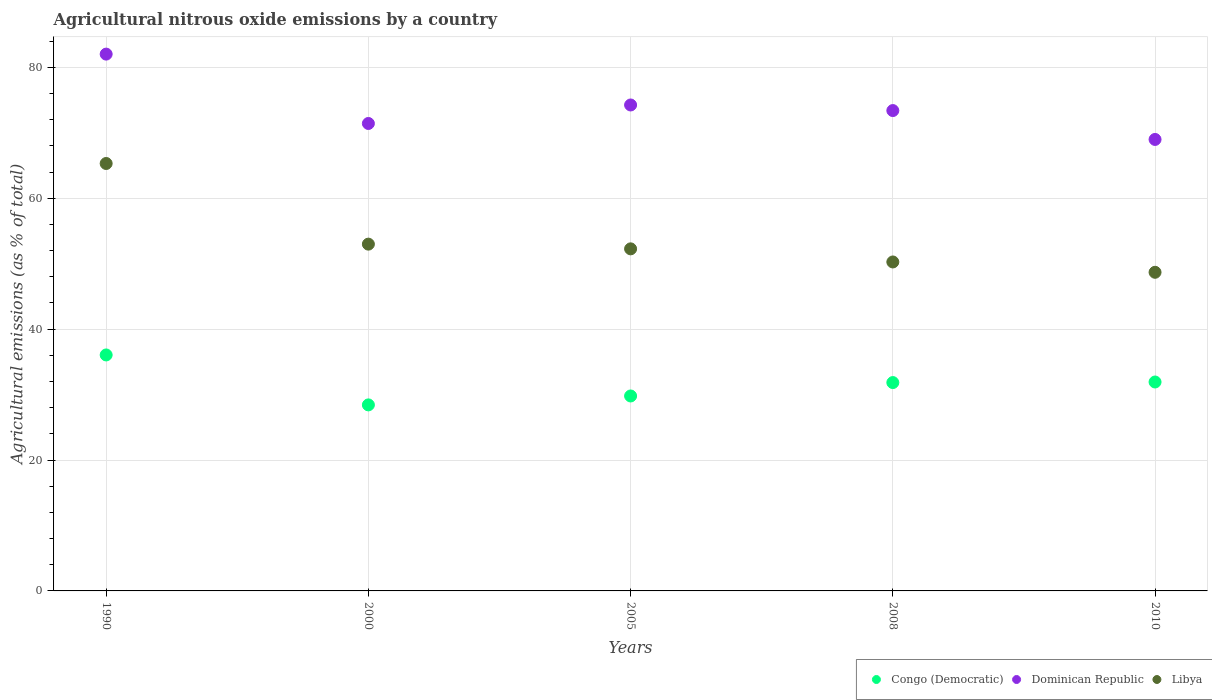What is the amount of agricultural nitrous oxide emitted in Libya in 2008?
Provide a short and direct response. 50.27. Across all years, what is the maximum amount of agricultural nitrous oxide emitted in Dominican Republic?
Offer a terse response. 82.03. Across all years, what is the minimum amount of agricultural nitrous oxide emitted in Congo (Democratic)?
Your answer should be compact. 28.43. In which year was the amount of agricultural nitrous oxide emitted in Congo (Democratic) minimum?
Ensure brevity in your answer.  2000. What is the total amount of agricultural nitrous oxide emitted in Libya in the graph?
Offer a terse response. 269.53. What is the difference between the amount of agricultural nitrous oxide emitted in Libya in 2000 and that in 2005?
Provide a short and direct response. 0.72. What is the difference between the amount of agricultural nitrous oxide emitted in Libya in 2000 and the amount of agricultural nitrous oxide emitted in Congo (Democratic) in 2008?
Offer a terse response. 21.15. What is the average amount of agricultural nitrous oxide emitted in Congo (Democratic) per year?
Your response must be concise. 31.61. In the year 2008, what is the difference between the amount of agricultural nitrous oxide emitted in Libya and amount of agricultural nitrous oxide emitted in Congo (Democratic)?
Give a very brief answer. 18.43. In how many years, is the amount of agricultural nitrous oxide emitted in Congo (Democratic) greater than 36 %?
Make the answer very short. 1. What is the ratio of the amount of agricultural nitrous oxide emitted in Libya in 2000 to that in 2010?
Offer a terse response. 1.09. Is the amount of agricultural nitrous oxide emitted in Dominican Republic in 1990 less than that in 2005?
Offer a very short reply. No. What is the difference between the highest and the second highest amount of agricultural nitrous oxide emitted in Libya?
Provide a succinct answer. 12.32. What is the difference between the highest and the lowest amount of agricultural nitrous oxide emitted in Libya?
Your answer should be very brief. 16.62. In how many years, is the amount of agricultural nitrous oxide emitted in Libya greater than the average amount of agricultural nitrous oxide emitted in Libya taken over all years?
Your answer should be very brief. 1. Does the amount of agricultural nitrous oxide emitted in Libya monotonically increase over the years?
Your answer should be very brief. No. Is the amount of agricultural nitrous oxide emitted in Congo (Democratic) strictly greater than the amount of agricultural nitrous oxide emitted in Dominican Republic over the years?
Ensure brevity in your answer.  No. Is the amount of agricultural nitrous oxide emitted in Congo (Democratic) strictly less than the amount of agricultural nitrous oxide emitted in Libya over the years?
Your answer should be very brief. Yes. Are the values on the major ticks of Y-axis written in scientific E-notation?
Ensure brevity in your answer.  No. Does the graph contain any zero values?
Your answer should be compact. No. Where does the legend appear in the graph?
Your response must be concise. Bottom right. How are the legend labels stacked?
Your answer should be compact. Horizontal. What is the title of the graph?
Keep it short and to the point. Agricultural nitrous oxide emissions by a country. What is the label or title of the Y-axis?
Make the answer very short. Agricultural emissions (as % of total). What is the Agricultural emissions (as % of total) in Congo (Democratic) in 1990?
Your answer should be compact. 36.06. What is the Agricultural emissions (as % of total) in Dominican Republic in 1990?
Make the answer very short. 82.03. What is the Agricultural emissions (as % of total) of Libya in 1990?
Your answer should be very brief. 65.31. What is the Agricultural emissions (as % of total) in Congo (Democratic) in 2000?
Provide a succinct answer. 28.43. What is the Agricultural emissions (as % of total) in Dominican Republic in 2000?
Provide a succinct answer. 71.43. What is the Agricultural emissions (as % of total) in Libya in 2000?
Offer a very short reply. 52.99. What is the Agricultural emissions (as % of total) of Congo (Democratic) in 2005?
Your answer should be very brief. 29.79. What is the Agricultural emissions (as % of total) in Dominican Republic in 2005?
Provide a succinct answer. 74.25. What is the Agricultural emissions (as % of total) in Libya in 2005?
Your answer should be compact. 52.27. What is the Agricultural emissions (as % of total) in Congo (Democratic) in 2008?
Your answer should be compact. 31.84. What is the Agricultural emissions (as % of total) of Dominican Republic in 2008?
Provide a short and direct response. 73.4. What is the Agricultural emissions (as % of total) in Libya in 2008?
Your answer should be compact. 50.27. What is the Agricultural emissions (as % of total) in Congo (Democratic) in 2010?
Offer a terse response. 31.92. What is the Agricultural emissions (as % of total) of Dominican Republic in 2010?
Offer a very short reply. 68.99. What is the Agricultural emissions (as % of total) of Libya in 2010?
Make the answer very short. 48.69. Across all years, what is the maximum Agricultural emissions (as % of total) of Congo (Democratic)?
Ensure brevity in your answer.  36.06. Across all years, what is the maximum Agricultural emissions (as % of total) in Dominican Republic?
Your answer should be very brief. 82.03. Across all years, what is the maximum Agricultural emissions (as % of total) in Libya?
Give a very brief answer. 65.31. Across all years, what is the minimum Agricultural emissions (as % of total) in Congo (Democratic)?
Offer a very short reply. 28.43. Across all years, what is the minimum Agricultural emissions (as % of total) of Dominican Republic?
Provide a succinct answer. 68.99. Across all years, what is the minimum Agricultural emissions (as % of total) in Libya?
Provide a succinct answer. 48.69. What is the total Agricultural emissions (as % of total) in Congo (Democratic) in the graph?
Keep it short and to the point. 158.03. What is the total Agricultural emissions (as % of total) of Dominican Republic in the graph?
Your response must be concise. 370.09. What is the total Agricultural emissions (as % of total) of Libya in the graph?
Provide a short and direct response. 269.53. What is the difference between the Agricultural emissions (as % of total) in Congo (Democratic) in 1990 and that in 2000?
Your response must be concise. 7.63. What is the difference between the Agricultural emissions (as % of total) in Dominican Republic in 1990 and that in 2000?
Your answer should be compact. 10.6. What is the difference between the Agricultural emissions (as % of total) in Libya in 1990 and that in 2000?
Offer a terse response. 12.32. What is the difference between the Agricultural emissions (as % of total) of Congo (Democratic) in 1990 and that in 2005?
Offer a very short reply. 6.27. What is the difference between the Agricultural emissions (as % of total) in Dominican Republic in 1990 and that in 2005?
Make the answer very short. 7.77. What is the difference between the Agricultural emissions (as % of total) in Libya in 1990 and that in 2005?
Give a very brief answer. 13.04. What is the difference between the Agricultural emissions (as % of total) of Congo (Democratic) in 1990 and that in 2008?
Your answer should be very brief. 4.22. What is the difference between the Agricultural emissions (as % of total) in Dominican Republic in 1990 and that in 2008?
Your answer should be compact. 8.63. What is the difference between the Agricultural emissions (as % of total) in Libya in 1990 and that in 2008?
Ensure brevity in your answer.  15.05. What is the difference between the Agricultural emissions (as % of total) in Congo (Democratic) in 1990 and that in 2010?
Your answer should be compact. 4.13. What is the difference between the Agricultural emissions (as % of total) of Dominican Republic in 1990 and that in 2010?
Your answer should be very brief. 13.04. What is the difference between the Agricultural emissions (as % of total) in Libya in 1990 and that in 2010?
Your answer should be compact. 16.62. What is the difference between the Agricultural emissions (as % of total) of Congo (Democratic) in 2000 and that in 2005?
Offer a terse response. -1.36. What is the difference between the Agricultural emissions (as % of total) in Dominican Republic in 2000 and that in 2005?
Offer a terse response. -2.83. What is the difference between the Agricultural emissions (as % of total) of Libya in 2000 and that in 2005?
Provide a short and direct response. 0.72. What is the difference between the Agricultural emissions (as % of total) in Congo (Democratic) in 2000 and that in 2008?
Make the answer very short. -3.41. What is the difference between the Agricultural emissions (as % of total) of Dominican Republic in 2000 and that in 2008?
Your answer should be very brief. -1.97. What is the difference between the Agricultural emissions (as % of total) in Libya in 2000 and that in 2008?
Ensure brevity in your answer.  2.72. What is the difference between the Agricultural emissions (as % of total) of Congo (Democratic) in 2000 and that in 2010?
Make the answer very short. -3.5. What is the difference between the Agricultural emissions (as % of total) of Dominican Republic in 2000 and that in 2010?
Make the answer very short. 2.44. What is the difference between the Agricultural emissions (as % of total) in Libya in 2000 and that in 2010?
Provide a succinct answer. 4.3. What is the difference between the Agricultural emissions (as % of total) in Congo (Democratic) in 2005 and that in 2008?
Your answer should be compact. -2.05. What is the difference between the Agricultural emissions (as % of total) in Dominican Republic in 2005 and that in 2008?
Ensure brevity in your answer.  0.85. What is the difference between the Agricultural emissions (as % of total) in Libya in 2005 and that in 2008?
Your answer should be very brief. 2. What is the difference between the Agricultural emissions (as % of total) of Congo (Democratic) in 2005 and that in 2010?
Provide a succinct answer. -2.13. What is the difference between the Agricultural emissions (as % of total) in Dominican Republic in 2005 and that in 2010?
Ensure brevity in your answer.  5.27. What is the difference between the Agricultural emissions (as % of total) of Libya in 2005 and that in 2010?
Make the answer very short. 3.58. What is the difference between the Agricultural emissions (as % of total) in Congo (Democratic) in 2008 and that in 2010?
Offer a terse response. -0.09. What is the difference between the Agricultural emissions (as % of total) of Dominican Republic in 2008 and that in 2010?
Provide a succinct answer. 4.41. What is the difference between the Agricultural emissions (as % of total) in Libya in 2008 and that in 2010?
Make the answer very short. 1.58. What is the difference between the Agricultural emissions (as % of total) of Congo (Democratic) in 1990 and the Agricultural emissions (as % of total) of Dominican Republic in 2000?
Keep it short and to the point. -35.37. What is the difference between the Agricultural emissions (as % of total) in Congo (Democratic) in 1990 and the Agricultural emissions (as % of total) in Libya in 2000?
Make the answer very short. -16.93. What is the difference between the Agricultural emissions (as % of total) in Dominican Republic in 1990 and the Agricultural emissions (as % of total) in Libya in 2000?
Offer a terse response. 29.04. What is the difference between the Agricultural emissions (as % of total) of Congo (Democratic) in 1990 and the Agricultural emissions (as % of total) of Dominican Republic in 2005?
Offer a very short reply. -38.2. What is the difference between the Agricultural emissions (as % of total) of Congo (Democratic) in 1990 and the Agricultural emissions (as % of total) of Libya in 2005?
Provide a succinct answer. -16.21. What is the difference between the Agricultural emissions (as % of total) in Dominican Republic in 1990 and the Agricultural emissions (as % of total) in Libya in 2005?
Make the answer very short. 29.76. What is the difference between the Agricultural emissions (as % of total) of Congo (Democratic) in 1990 and the Agricultural emissions (as % of total) of Dominican Republic in 2008?
Give a very brief answer. -37.34. What is the difference between the Agricultural emissions (as % of total) of Congo (Democratic) in 1990 and the Agricultural emissions (as % of total) of Libya in 2008?
Offer a terse response. -14.21. What is the difference between the Agricultural emissions (as % of total) of Dominican Republic in 1990 and the Agricultural emissions (as % of total) of Libya in 2008?
Give a very brief answer. 31.76. What is the difference between the Agricultural emissions (as % of total) of Congo (Democratic) in 1990 and the Agricultural emissions (as % of total) of Dominican Republic in 2010?
Keep it short and to the point. -32.93. What is the difference between the Agricultural emissions (as % of total) in Congo (Democratic) in 1990 and the Agricultural emissions (as % of total) in Libya in 2010?
Ensure brevity in your answer.  -12.63. What is the difference between the Agricultural emissions (as % of total) in Dominican Republic in 1990 and the Agricultural emissions (as % of total) in Libya in 2010?
Make the answer very short. 33.34. What is the difference between the Agricultural emissions (as % of total) in Congo (Democratic) in 2000 and the Agricultural emissions (as % of total) in Dominican Republic in 2005?
Offer a very short reply. -45.83. What is the difference between the Agricultural emissions (as % of total) in Congo (Democratic) in 2000 and the Agricultural emissions (as % of total) in Libya in 2005?
Keep it short and to the point. -23.84. What is the difference between the Agricultural emissions (as % of total) of Dominican Republic in 2000 and the Agricultural emissions (as % of total) of Libya in 2005?
Your answer should be compact. 19.16. What is the difference between the Agricultural emissions (as % of total) in Congo (Democratic) in 2000 and the Agricultural emissions (as % of total) in Dominican Republic in 2008?
Your answer should be very brief. -44.97. What is the difference between the Agricultural emissions (as % of total) in Congo (Democratic) in 2000 and the Agricultural emissions (as % of total) in Libya in 2008?
Make the answer very short. -21.84. What is the difference between the Agricultural emissions (as % of total) in Dominican Republic in 2000 and the Agricultural emissions (as % of total) in Libya in 2008?
Keep it short and to the point. 21.16. What is the difference between the Agricultural emissions (as % of total) in Congo (Democratic) in 2000 and the Agricultural emissions (as % of total) in Dominican Republic in 2010?
Offer a terse response. -40.56. What is the difference between the Agricultural emissions (as % of total) in Congo (Democratic) in 2000 and the Agricultural emissions (as % of total) in Libya in 2010?
Your answer should be very brief. -20.26. What is the difference between the Agricultural emissions (as % of total) of Dominican Republic in 2000 and the Agricultural emissions (as % of total) of Libya in 2010?
Your answer should be compact. 22.74. What is the difference between the Agricultural emissions (as % of total) of Congo (Democratic) in 2005 and the Agricultural emissions (as % of total) of Dominican Republic in 2008?
Your response must be concise. -43.61. What is the difference between the Agricultural emissions (as % of total) in Congo (Democratic) in 2005 and the Agricultural emissions (as % of total) in Libya in 2008?
Ensure brevity in your answer.  -20.48. What is the difference between the Agricultural emissions (as % of total) in Dominican Republic in 2005 and the Agricultural emissions (as % of total) in Libya in 2008?
Give a very brief answer. 23.99. What is the difference between the Agricultural emissions (as % of total) in Congo (Democratic) in 2005 and the Agricultural emissions (as % of total) in Dominican Republic in 2010?
Make the answer very short. -39.2. What is the difference between the Agricultural emissions (as % of total) of Congo (Democratic) in 2005 and the Agricultural emissions (as % of total) of Libya in 2010?
Offer a terse response. -18.9. What is the difference between the Agricultural emissions (as % of total) of Dominican Republic in 2005 and the Agricultural emissions (as % of total) of Libya in 2010?
Your answer should be very brief. 25.57. What is the difference between the Agricultural emissions (as % of total) of Congo (Democratic) in 2008 and the Agricultural emissions (as % of total) of Dominican Republic in 2010?
Provide a succinct answer. -37.15. What is the difference between the Agricultural emissions (as % of total) in Congo (Democratic) in 2008 and the Agricultural emissions (as % of total) in Libya in 2010?
Give a very brief answer. -16.85. What is the difference between the Agricultural emissions (as % of total) of Dominican Republic in 2008 and the Agricultural emissions (as % of total) of Libya in 2010?
Give a very brief answer. 24.71. What is the average Agricultural emissions (as % of total) of Congo (Democratic) per year?
Ensure brevity in your answer.  31.61. What is the average Agricultural emissions (as % of total) in Dominican Republic per year?
Provide a short and direct response. 74.02. What is the average Agricultural emissions (as % of total) of Libya per year?
Provide a succinct answer. 53.91. In the year 1990, what is the difference between the Agricultural emissions (as % of total) of Congo (Democratic) and Agricultural emissions (as % of total) of Dominican Republic?
Provide a short and direct response. -45.97. In the year 1990, what is the difference between the Agricultural emissions (as % of total) of Congo (Democratic) and Agricultural emissions (as % of total) of Libya?
Provide a succinct answer. -29.25. In the year 1990, what is the difference between the Agricultural emissions (as % of total) of Dominican Republic and Agricultural emissions (as % of total) of Libya?
Keep it short and to the point. 16.71. In the year 2000, what is the difference between the Agricultural emissions (as % of total) in Congo (Democratic) and Agricultural emissions (as % of total) in Dominican Republic?
Provide a short and direct response. -43. In the year 2000, what is the difference between the Agricultural emissions (as % of total) of Congo (Democratic) and Agricultural emissions (as % of total) of Libya?
Make the answer very short. -24.56. In the year 2000, what is the difference between the Agricultural emissions (as % of total) of Dominican Republic and Agricultural emissions (as % of total) of Libya?
Your answer should be very brief. 18.44. In the year 2005, what is the difference between the Agricultural emissions (as % of total) in Congo (Democratic) and Agricultural emissions (as % of total) in Dominican Republic?
Your response must be concise. -44.46. In the year 2005, what is the difference between the Agricultural emissions (as % of total) in Congo (Democratic) and Agricultural emissions (as % of total) in Libya?
Your response must be concise. -22.48. In the year 2005, what is the difference between the Agricultural emissions (as % of total) in Dominican Republic and Agricultural emissions (as % of total) in Libya?
Give a very brief answer. 21.98. In the year 2008, what is the difference between the Agricultural emissions (as % of total) of Congo (Democratic) and Agricultural emissions (as % of total) of Dominican Republic?
Keep it short and to the point. -41.56. In the year 2008, what is the difference between the Agricultural emissions (as % of total) in Congo (Democratic) and Agricultural emissions (as % of total) in Libya?
Your answer should be very brief. -18.43. In the year 2008, what is the difference between the Agricultural emissions (as % of total) in Dominican Republic and Agricultural emissions (as % of total) in Libya?
Give a very brief answer. 23.13. In the year 2010, what is the difference between the Agricultural emissions (as % of total) in Congo (Democratic) and Agricultural emissions (as % of total) in Dominican Republic?
Give a very brief answer. -37.06. In the year 2010, what is the difference between the Agricultural emissions (as % of total) of Congo (Democratic) and Agricultural emissions (as % of total) of Libya?
Provide a short and direct response. -16.76. In the year 2010, what is the difference between the Agricultural emissions (as % of total) in Dominican Republic and Agricultural emissions (as % of total) in Libya?
Provide a short and direct response. 20.3. What is the ratio of the Agricultural emissions (as % of total) in Congo (Democratic) in 1990 to that in 2000?
Provide a succinct answer. 1.27. What is the ratio of the Agricultural emissions (as % of total) of Dominican Republic in 1990 to that in 2000?
Ensure brevity in your answer.  1.15. What is the ratio of the Agricultural emissions (as % of total) of Libya in 1990 to that in 2000?
Your answer should be compact. 1.23. What is the ratio of the Agricultural emissions (as % of total) in Congo (Democratic) in 1990 to that in 2005?
Provide a succinct answer. 1.21. What is the ratio of the Agricultural emissions (as % of total) of Dominican Republic in 1990 to that in 2005?
Give a very brief answer. 1.1. What is the ratio of the Agricultural emissions (as % of total) of Libya in 1990 to that in 2005?
Offer a very short reply. 1.25. What is the ratio of the Agricultural emissions (as % of total) of Congo (Democratic) in 1990 to that in 2008?
Provide a short and direct response. 1.13. What is the ratio of the Agricultural emissions (as % of total) of Dominican Republic in 1990 to that in 2008?
Your response must be concise. 1.12. What is the ratio of the Agricultural emissions (as % of total) in Libya in 1990 to that in 2008?
Keep it short and to the point. 1.3. What is the ratio of the Agricultural emissions (as % of total) in Congo (Democratic) in 1990 to that in 2010?
Your answer should be very brief. 1.13. What is the ratio of the Agricultural emissions (as % of total) in Dominican Republic in 1990 to that in 2010?
Offer a very short reply. 1.19. What is the ratio of the Agricultural emissions (as % of total) in Libya in 1990 to that in 2010?
Provide a short and direct response. 1.34. What is the ratio of the Agricultural emissions (as % of total) in Congo (Democratic) in 2000 to that in 2005?
Offer a very short reply. 0.95. What is the ratio of the Agricultural emissions (as % of total) in Dominican Republic in 2000 to that in 2005?
Your response must be concise. 0.96. What is the ratio of the Agricultural emissions (as % of total) in Libya in 2000 to that in 2005?
Your answer should be very brief. 1.01. What is the ratio of the Agricultural emissions (as % of total) of Congo (Democratic) in 2000 to that in 2008?
Offer a terse response. 0.89. What is the ratio of the Agricultural emissions (as % of total) in Dominican Republic in 2000 to that in 2008?
Offer a terse response. 0.97. What is the ratio of the Agricultural emissions (as % of total) in Libya in 2000 to that in 2008?
Offer a very short reply. 1.05. What is the ratio of the Agricultural emissions (as % of total) in Congo (Democratic) in 2000 to that in 2010?
Make the answer very short. 0.89. What is the ratio of the Agricultural emissions (as % of total) in Dominican Republic in 2000 to that in 2010?
Make the answer very short. 1.04. What is the ratio of the Agricultural emissions (as % of total) in Libya in 2000 to that in 2010?
Keep it short and to the point. 1.09. What is the ratio of the Agricultural emissions (as % of total) of Congo (Democratic) in 2005 to that in 2008?
Make the answer very short. 0.94. What is the ratio of the Agricultural emissions (as % of total) of Dominican Republic in 2005 to that in 2008?
Make the answer very short. 1.01. What is the ratio of the Agricultural emissions (as % of total) of Libya in 2005 to that in 2008?
Keep it short and to the point. 1.04. What is the ratio of the Agricultural emissions (as % of total) of Congo (Democratic) in 2005 to that in 2010?
Offer a terse response. 0.93. What is the ratio of the Agricultural emissions (as % of total) in Dominican Republic in 2005 to that in 2010?
Keep it short and to the point. 1.08. What is the ratio of the Agricultural emissions (as % of total) of Libya in 2005 to that in 2010?
Offer a very short reply. 1.07. What is the ratio of the Agricultural emissions (as % of total) of Dominican Republic in 2008 to that in 2010?
Your response must be concise. 1.06. What is the ratio of the Agricultural emissions (as % of total) of Libya in 2008 to that in 2010?
Your response must be concise. 1.03. What is the difference between the highest and the second highest Agricultural emissions (as % of total) of Congo (Democratic)?
Offer a terse response. 4.13. What is the difference between the highest and the second highest Agricultural emissions (as % of total) of Dominican Republic?
Provide a short and direct response. 7.77. What is the difference between the highest and the second highest Agricultural emissions (as % of total) of Libya?
Provide a succinct answer. 12.32. What is the difference between the highest and the lowest Agricultural emissions (as % of total) in Congo (Democratic)?
Offer a very short reply. 7.63. What is the difference between the highest and the lowest Agricultural emissions (as % of total) in Dominican Republic?
Offer a terse response. 13.04. What is the difference between the highest and the lowest Agricultural emissions (as % of total) of Libya?
Ensure brevity in your answer.  16.62. 